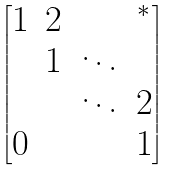Convert formula to latex. <formula><loc_0><loc_0><loc_500><loc_500>\begin{bmatrix} 1 & 2 & & ^ { * } \\ & 1 & \ddots & \\ & & \ddots & 2 \\ 0 & & & 1 \end{bmatrix}</formula> 